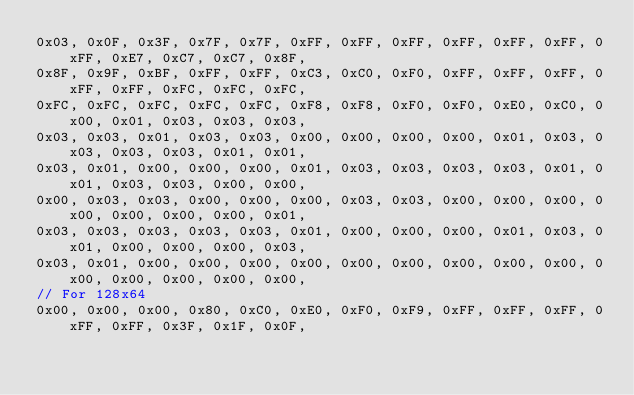<code> <loc_0><loc_0><loc_500><loc_500><_C++_>0x03, 0x0F, 0x3F, 0x7F, 0x7F, 0xFF, 0xFF, 0xFF, 0xFF, 0xFF, 0xFF, 0xFF, 0xE7, 0xC7, 0xC7, 0x8F,
0x8F, 0x9F, 0xBF, 0xFF, 0xFF, 0xC3, 0xC0, 0xF0, 0xFF, 0xFF, 0xFF, 0xFF, 0xFF, 0xFC, 0xFC, 0xFC,
0xFC, 0xFC, 0xFC, 0xFC, 0xFC, 0xF8, 0xF8, 0xF0, 0xF0, 0xE0, 0xC0, 0x00, 0x01, 0x03, 0x03, 0x03,
0x03, 0x03, 0x01, 0x03, 0x03, 0x00, 0x00, 0x00, 0x00, 0x01, 0x03, 0x03, 0x03, 0x03, 0x01, 0x01,
0x03, 0x01, 0x00, 0x00, 0x00, 0x01, 0x03, 0x03, 0x03, 0x03, 0x01, 0x01, 0x03, 0x03, 0x00, 0x00,
0x00, 0x03, 0x03, 0x00, 0x00, 0x00, 0x03, 0x03, 0x00, 0x00, 0x00, 0x00, 0x00, 0x00, 0x00, 0x01,
0x03, 0x03, 0x03, 0x03, 0x03, 0x01, 0x00, 0x00, 0x00, 0x01, 0x03, 0x01, 0x00, 0x00, 0x00, 0x03,
0x03, 0x01, 0x00, 0x00, 0x00, 0x00, 0x00, 0x00, 0x00, 0x00, 0x00, 0x00, 0x00, 0x00, 0x00, 0x00,
// For 128x64
0x00, 0x00, 0x00, 0x80, 0xC0, 0xE0, 0xF0, 0xF9, 0xFF, 0xFF, 0xFF, 0xFF, 0xFF, 0x3F, 0x1F, 0x0F,</code> 